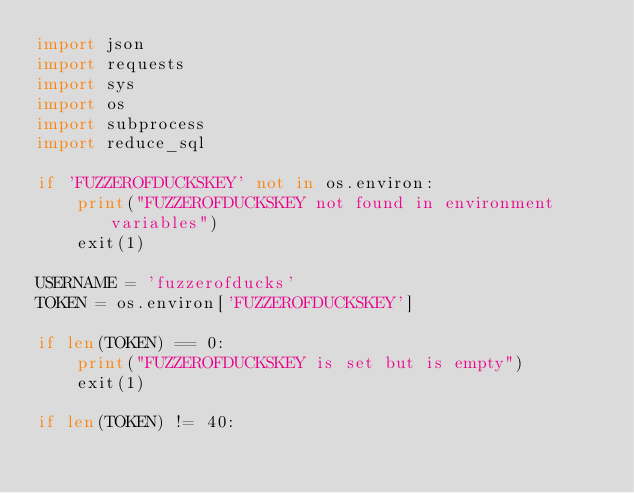<code> <loc_0><loc_0><loc_500><loc_500><_Python_>import json
import requests
import sys
import os
import subprocess
import reduce_sql

if 'FUZZEROFDUCKSKEY' not in os.environ:
    print("FUZZEROFDUCKSKEY not found in environment variables")
    exit(1)

USERNAME = 'fuzzerofducks'
TOKEN = os.environ['FUZZEROFDUCKSKEY']

if len(TOKEN) == 0:
    print("FUZZEROFDUCKSKEY is set but is empty")
    exit(1)

if len(TOKEN) != 40:</code> 